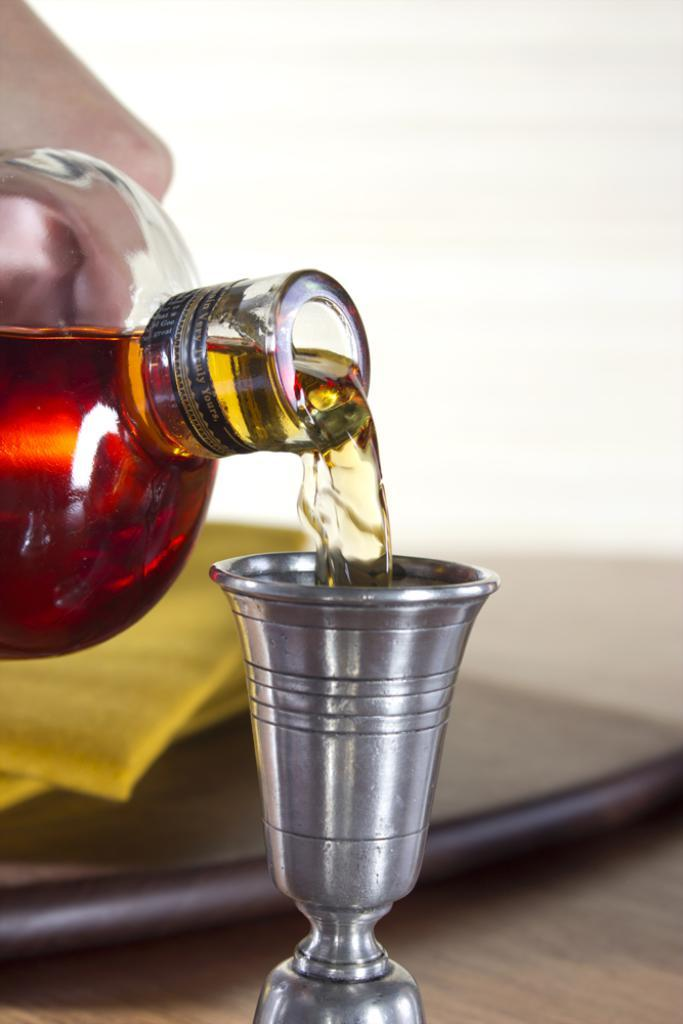Who is in the image? There is a person in the image. What is the person doing in the image? The person is pouring wine. What is the wine being poured into? The wine is being poured into a glass. Where is the glass located? The glass is on a table. What else is on the table? There is a plate on the table. How many tickets can be seen in the image? There are no tickets present in the image. What type of yarn is being used to knit the person's sweater in the image? The person in the image is not wearing a sweater, nor is there any yarn visible. 